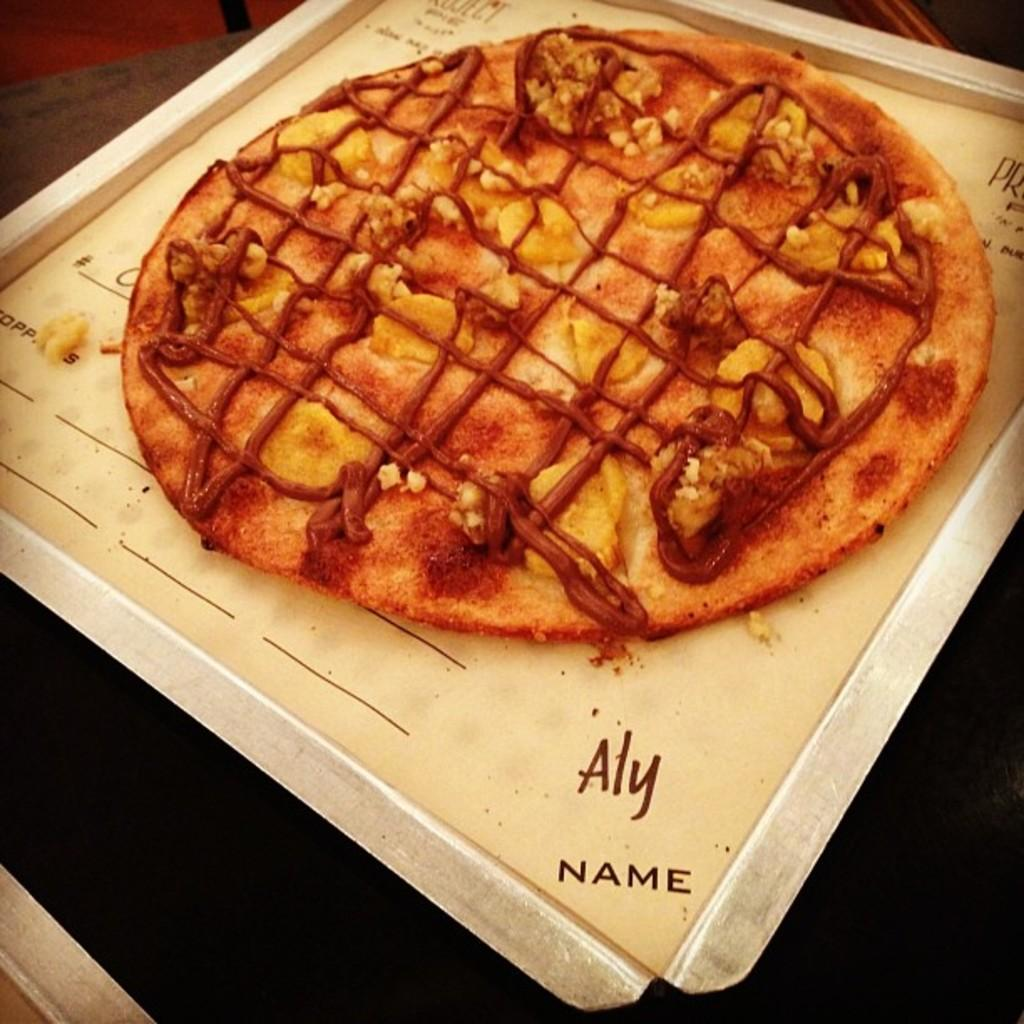What is on the tray that is visible in the image? The tray contains pizza in the image. What type of food is present on the tray? The food on the tray is pizza. What is the color of the table in the image? The table is black in the image. How many cars are parked on the table in the image? There are no cars present on the table in the image. Can you see a person interacting with the pizza on the tray in the image? There is no person visible in the image. What type of animals can be seen at the zoo in the image? There is no zoo present in the image. 